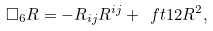Convert formula to latex. <formula><loc_0><loc_0><loc_500><loc_500>\square _ { 6 } R = - R _ { i j } R ^ { i j } + \ f t 1 2 R ^ { 2 } ,</formula> 